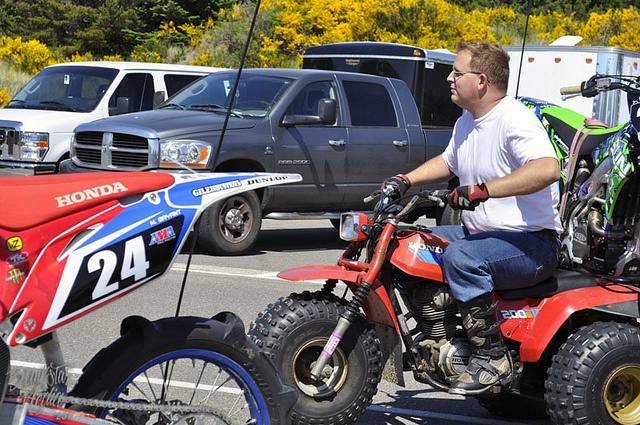Describe the objects in this image and their specific colors. I can see motorcycle in black, white, darkgray, and salmon tones, truck in black, gray, and navy tones, people in black, white, and gray tones, motorcycle in black, gray, darkgray, and lightgray tones, and car in black, white, gray, and navy tones in this image. 